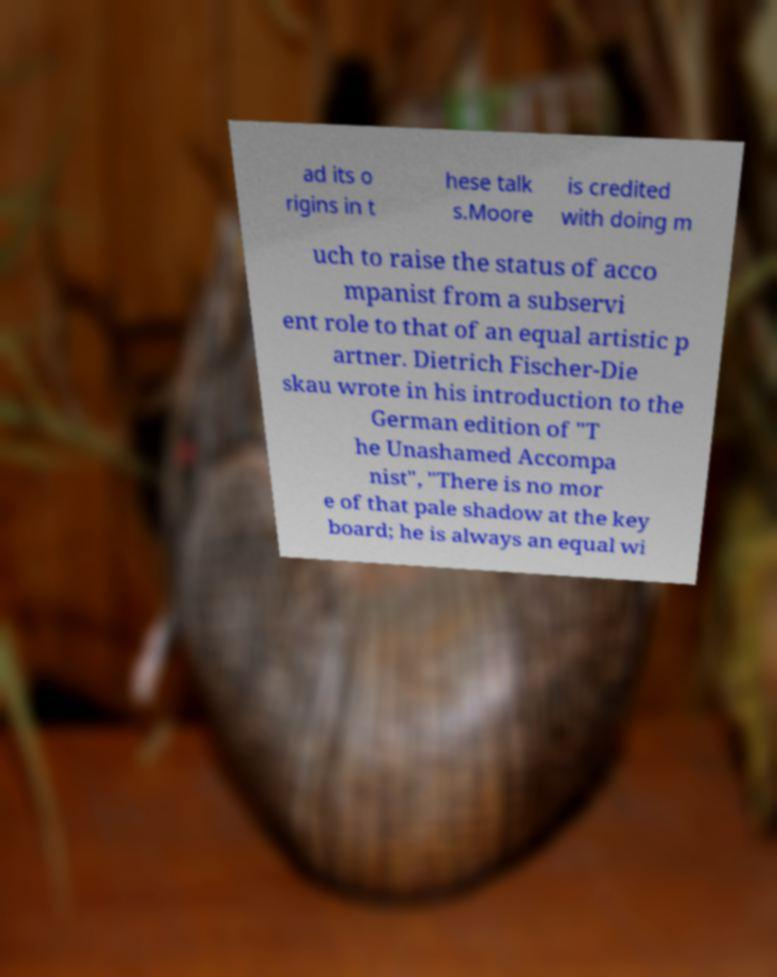Please identify and transcribe the text found in this image. ad its o rigins in t hese talk s.Moore is credited with doing m uch to raise the status of acco mpanist from a subservi ent role to that of an equal artistic p artner. Dietrich Fischer-Die skau wrote in his introduction to the German edition of "T he Unashamed Accompa nist", "There is no mor e of that pale shadow at the key board; he is always an equal wi 